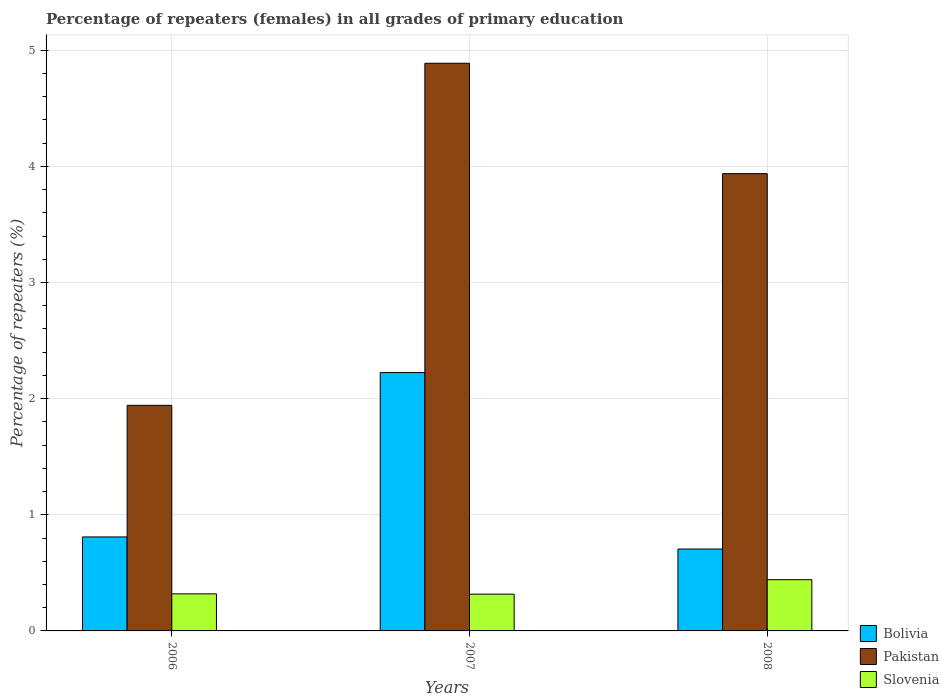Are the number of bars per tick equal to the number of legend labels?
Offer a terse response. Yes. Are the number of bars on each tick of the X-axis equal?
Give a very brief answer. Yes. How many bars are there on the 2nd tick from the right?
Provide a succinct answer. 3. What is the label of the 1st group of bars from the left?
Keep it short and to the point. 2006. In how many cases, is the number of bars for a given year not equal to the number of legend labels?
Your answer should be compact. 0. What is the percentage of repeaters (females) in Pakistan in 2007?
Provide a short and direct response. 4.89. Across all years, what is the maximum percentage of repeaters (females) in Pakistan?
Provide a short and direct response. 4.89. Across all years, what is the minimum percentage of repeaters (females) in Pakistan?
Make the answer very short. 1.94. What is the total percentage of repeaters (females) in Pakistan in the graph?
Your answer should be very brief. 10.77. What is the difference between the percentage of repeaters (females) in Bolivia in 2006 and that in 2007?
Provide a succinct answer. -1.41. What is the difference between the percentage of repeaters (females) in Slovenia in 2007 and the percentage of repeaters (females) in Bolivia in 2006?
Ensure brevity in your answer.  -0.49. What is the average percentage of repeaters (females) in Bolivia per year?
Ensure brevity in your answer.  1.25. In the year 2006, what is the difference between the percentage of repeaters (females) in Bolivia and percentage of repeaters (females) in Pakistan?
Make the answer very short. -1.13. What is the ratio of the percentage of repeaters (females) in Bolivia in 2007 to that in 2008?
Offer a very short reply. 3.15. Is the difference between the percentage of repeaters (females) in Bolivia in 2007 and 2008 greater than the difference between the percentage of repeaters (females) in Pakistan in 2007 and 2008?
Provide a succinct answer. Yes. What is the difference between the highest and the second highest percentage of repeaters (females) in Pakistan?
Your answer should be very brief. 0.95. What is the difference between the highest and the lowest percentage of repeaters (females) in Slovenia?
Make the answer very short. 0.12. What does the 2nd bar from the left in 2006 represents?
Give a very brief answer. Pakistan. Is it the case that in every year, the sum of the percentage of repeaters (females) in Slovenia and percentage of repeaters (females) in Pakistan is greater than the percentage of repeaters (females) in Bolivia?
Keep it short and to the point. Yes. How many bars are there?
Your answer should be very brief. 9. What is the difference between two consecutive major ticks on the Y-axis?
Offer a terse response. 1. Are the values on the major ticks of Y-axis written in scientific E-notation?
Ensure brevity in your answer.  No. Does the graph contain any zero values?
Provide a succinct answer. No. How are the legend labels stacked?
Provide a short and direct response. Vertical. What is the title of the graph?
Offer a very short reply. Percentage of repeaters (females) in all grades of primary education. Does "Colombia" appear as one of the legend labels in the graph?
Make the answer very short. No. What is the label or title of the Y-axis?
Offer a very short reply. Percentage of repeaters (%). What is the Percentage of repeaters (%) of Bolivia in 2006?
Your response must be concise. 0.81. What is the Percentage of repeaters (%) in Pakistan in 2006?
Provide a succinct answer. 1.94. What is the Percentage of repeaters (%) of Slovenia in 2006?
Give a very brief answer. 0.32. What is the Percentage of repeaters (%) of Bolivia in 2007?
Offer a terse response. 2.22. What is the Percentage of repeaters (%) of Pakistan in 2007?
Provide a succinct answer. 4.89. What is the Percentage of repeaters (%) in Slovenia in 2007?
Provide a succinct answer. 0.32. What is the Percentage of repeaters (%) of Bolivia in 2008?
Your response must be concise. 0.71. What is the Percentage of repeaters (%) of Pakistan in 2008?
Provide a succinct answer. 3.94. What is the Percentage of repeaters (%) in Slovenia in 2008?
Keep it short and to the point. 0.44. Across all years, what is the maximum Percentage of repeaters (%) in Bolivia?
Make the answer very short. 2.22. Across all years, what is the maximum Percentage of repeaters (%) of Pakistan?
Give a very brief answer. 4.89. Across all years, what is the maximum Percentage of repeaters (%) of Slovenia?
Keep it short and to the point. 0.44. Across all years, what is the minimum Percentage of repeaters (%) in Bolivia?
Give a very brief answer. 0.71. Across all years, what is the minimum Percentage of repeaters (%) of Pakistan?
Provide a short and direct response. 1.94. Across all years, what is the minimum Percentage of repeaters (%) in Slovenia?
Ensure brevity in your answer.  0.32. What is the total Percentage of repeaters (%) in Bolivia in the graph?
Offer a very short reply. 3.74. What is the total Percentage of repeaters (%) of Pakistan in the graph?
Make the answer very short. 10.77. What is the total Percentage of repeaters (%) in Slovenia in the graph?
Offer a terse response. 1.08. What is the difference between the Percentage of repeaters (%) of Bolivia in 2006 and that in 2007?
Keep it short and to the point. -1.41. What is the difference between the Percentage of repeaters (%) in Pakistan in 2006 and that in 2007?
Provide a short and direct response. -2.95. What is the difference between the Percentage of repeaters (%) of Slovenia in 2006 and that in 2007?
Make the answer very short. 0. What is the difference between the Percentage of repeaters (%) in Bolivia in 2006 and that in 2008?
Ensure brevity in your answer.  0.1. What is the difference between the Percentage of repeaters (%) of Pakistan in 2006 and that in 2008?
Provide a short and direct response. -2. What is the difference between the Percentage of repeaters (%) of Slovenia in 2006 and that in 2008?
Provide a short and direct response. -0.12. What is the difference between the Percentage of repeaters (%) of Bolivia in 2007 and that in 2008?
Keep it short and to the point. 1.52. What is the difference between the Percentage of repeaters (%) in Pakistan in 2007 and that in 2008?
Provide a succinct answer. 0.95. What is the difference between the Percentage of repeaters (%) in Slovenia in 2007 and that in 2008?
Ensure brevity in your answer.  -0.12. What is the difference between the Percentage of repeaters (%) in Bolivia in 2006 and the Percentage of repeaters (%) in Pakistan in 2007?
Give a very brief answer. -4.08. What is the difference between the Percentage of repeaters (%) of Bolivia in 2006 and the Percentage of repeaters (%) of Slovenia in 2007?
Ensure brevity in your answer.  0.49. What is the difference between the Percentage of repeaters (%) of Pakistan in 2006 and the Percentage of repeaters (%) of Slovenia in 2007?
Give a very brief answer. 1.63. What is the difference between the Percentage of repeaters (%) in Bolivia in 2006 and the Percentage of repeaters (%) in Pakistan in 2008?
Keep it short and to the point. -3.13. What is the difference between the Percentage of repeaters (%) in Bolivia in 2006 and the Percentage of repeaters (%) in Slovenia in 2008?
Give a very brief answer. 0.37. What is the difference between the Percentage of repeaters (%) in Pakistan in 2006 and the Percentage of repeaters (%) in Slovenia in 2008?
Your answer should be very brief. 1.5. What is the difference between the Percentage of repeaters (%) in Bolivia in 2007 and the Percentage of repeaters (%) in Pakistan in 2008?
Your answer should be compact. -1.71. What is the difference between the Percentage of repeaters (%) of Bolivia in 2007 and the Percentage of repeaters (%) of Slovenia in 2008?
Your answer should be compact. 1.78. What is the difference between the Percentage of repeaters (%) in Pakistan in 2007 and the Percentage of repeaters (%) in Slovenia in 2008?
Your answer should be compact. 4.45. What is the average Percentage of repeaters (%) in Bolivia per year?
Ensure brevity in your answer.  1.25. What is the average Percentage of repeaters (%) in Pakistan per year?
Make the answer very short. 3.59. What is the average Percentage of repeaters (%) of Slovenia per year?
Give a very brief answer. 0.36. In the year 2006, what is the difference between the Percentage of repeaters (%) of Bolivia and Percentage of repeaters (%) of Pakistan?
Your answer should be very brief. -1.13. In the year 2006, what is the difference between the Percentage of repeaters (%) in Bolivia and Percentage of repeaters (%) in Slovenia?
Ensure brevity in your answer.  0.49. In the year 2006, what is the difference between the Percentage of repeaters (%) of Pakistan and Percentage of repeaters (%) of Slovenia?
Give a very brief answer. 1.62. In the year 2007, what is the difference between the Percentage of repeaters (%) in Bolivia and Percentage of repeaters (%) in Pakistan?
Provide a short and direct response. -2.66. In the year 2007, what is the difference between the Percentage of repeaters (%) in Bolivia and Percentage of repeaters (%) in Slovenia?
Offer a very short reply. 1.91. In the year 2007, what is the difference between the Percentage of repeaters (%) of Pakistan and Percentage of repeaters (%) of Slovenia?
Keep it short and to the point. 4.57. In the year 2008, what is the difference between the Percentage of repeaters (%) of Bolivia and Percentage of repeaters (%) of Pakistan?
Offer a terse response. -3.23. In the year 2008, what is the difference between the Percentage of repeaters (%) in Bolivia and Percentage of repeaters (%) in Slovenia?
Keep it short and to the point. 0.26. In the year 2008, what is the difference between the Percentage of repeaters (%) in Pakistan and Percentage of repeaters (%) in Slovenia?
Ensure brevity in your answer.  3.5. What is the ratio of the Percentage of repeaters (%) of Bolivia in 2006 to that in 2007?
Your answer should be very brief. 0.36. What is the ratio of the Percentage of repeaters (%) of Pakistan in 2006 to that in 2007?
Offer a terse response. 0.4. What is the ratio of the Percentage of repeaters (%) of Slovenia in 2006 to that in 2007?
Keep it short and to the point. 1.01. What is the ratio of the Percentage of repeaters (%) of Bolivia in 2006 to that in 2008?
Your answer should be compact. 1.15. What is the ratio of the Percentage of repeaters (%) in Pakistan in 2006 to that in 2008?
Your answer should be compact. 0.49. What is the ratio of the Percentage of repeaters (%) in Slovenia in 2006 to that in 2008?
Your answer should be very brief. 0.72. What is the ratio of the Percentage of repeaters (%) of Bolivia in 2007 to that in 2008?
Give a very brief answer. 3.15. What is the ratio of the Percentage of repeaters (%) in Pakistan in 2007 to that in 2008?
Ensure brevity in your answer.  1.24. What is the ratio of the Percentage of repeaters (%) of Slovenia in 2007 to that in 2008?
Your answer should be compact. 0.72. What is the difference between the highest and the second highest Percentage of repeaters (%) of Bolivia?
Your response must be concise. 1.41. What is the difference between the highest and the second highest Percentage of repeaters (%) in Pakistan?
Provide a succinct answer. 0.95. What is the difference between the highest and the second highest Percentage of repeaters (%) of Slovenia?
Your response must be concise. 0.12. What is the difference between the highest and the lowest Percentage of repeaters (%) in Bolivia?
Provide a short and direct response. 1.52. What is the difference between the highest and the lowest Percentage of repeaters (%) of Pakistan?
Provide a succinct answer. 2.95. What is the difference between the highest and the lowest Percentage of repeaters (%) in Slovenia?
Give a very brief answer. 0.12. 